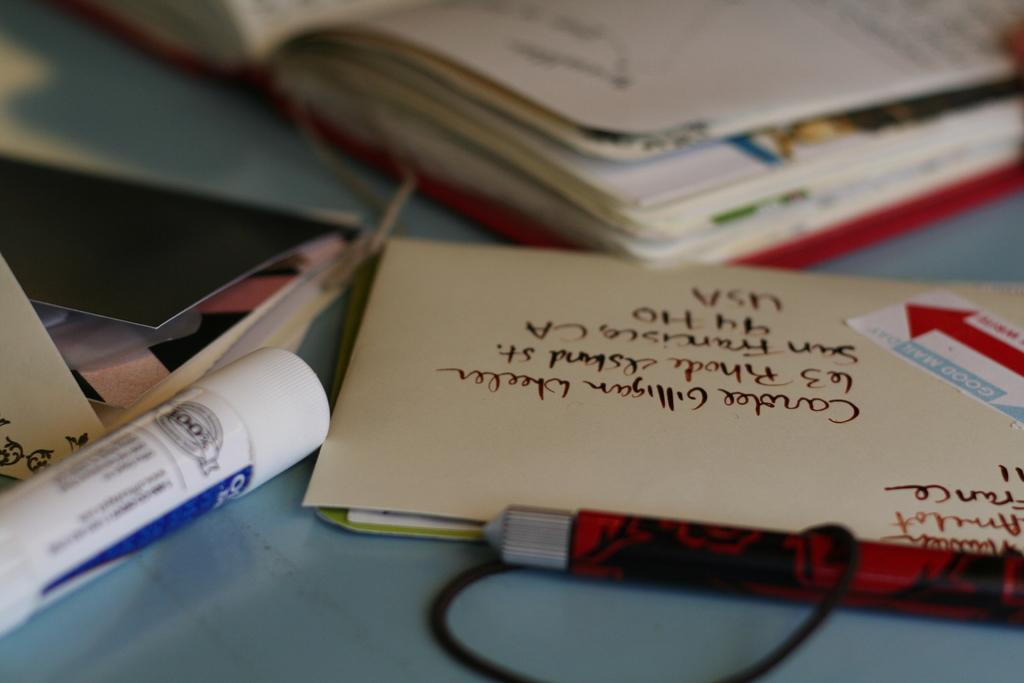Provide a one-sentence caption for the provided image. The envelope is being mailed to San Francisco California. 